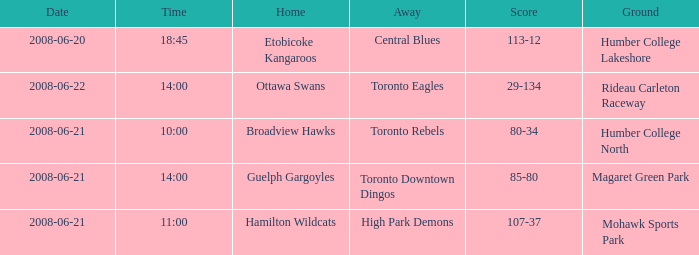What is the Away with a Ground that is humber college north? Toronto Rebels. 